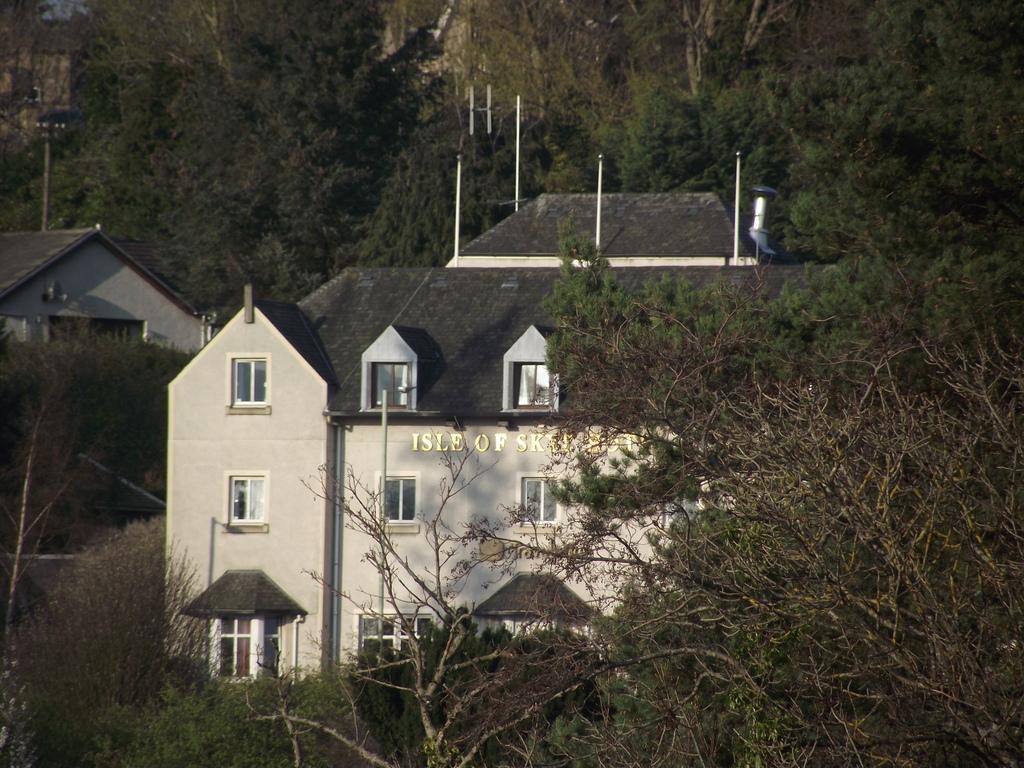Could you give a brief overview of what you see in this image? In the foreground of this image, there are trees around two houses. 